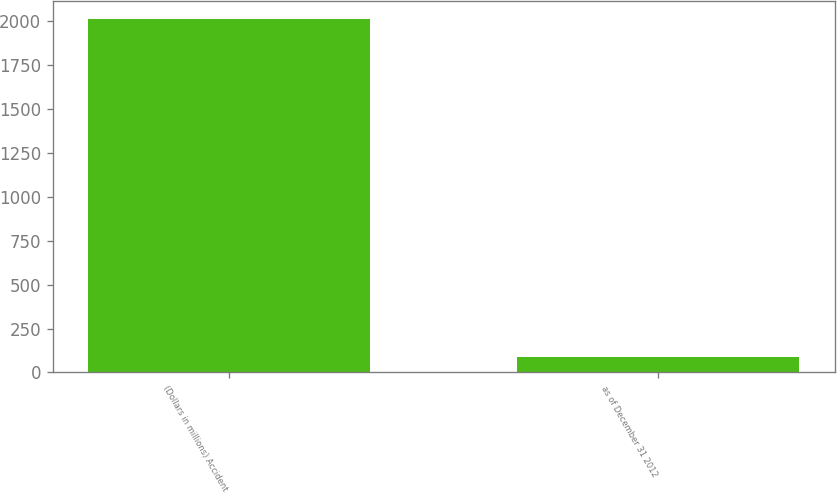Convert chart to OTSL. <chart><loc_0><loc_0><loc_500><loc_500><bar_chart><fcel>(Dollars in millions) Accident<fcel>as of December 31 2012<nl><fcel>2012<fcel>86.6<nl></chart> 